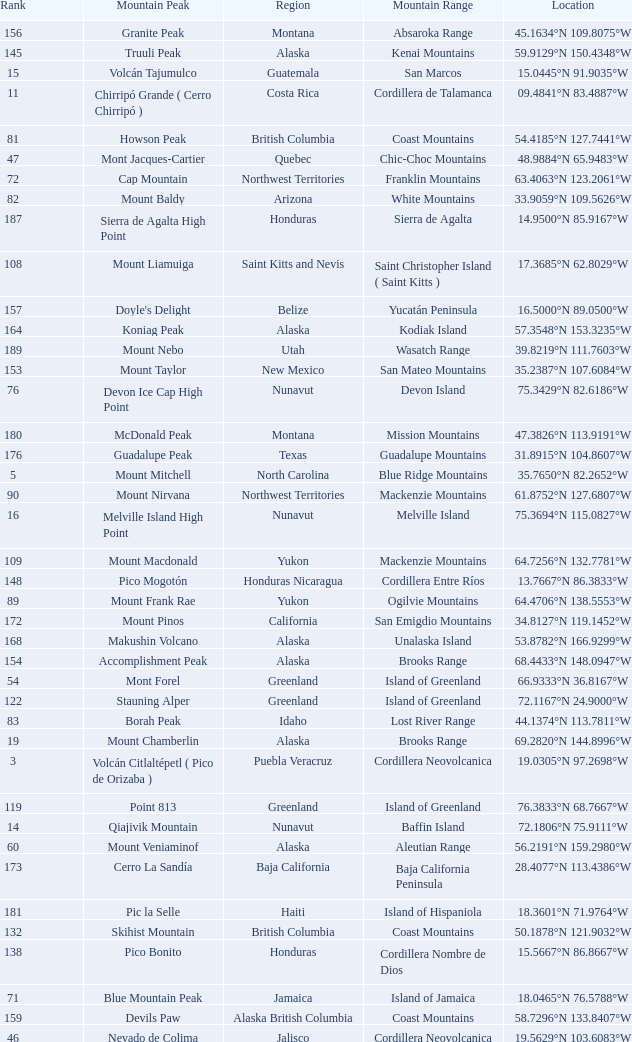Which Mountain Range has a Region of haiti, and a Location of 18.3601°n 71.9764°w? Island of Hispaniola. 